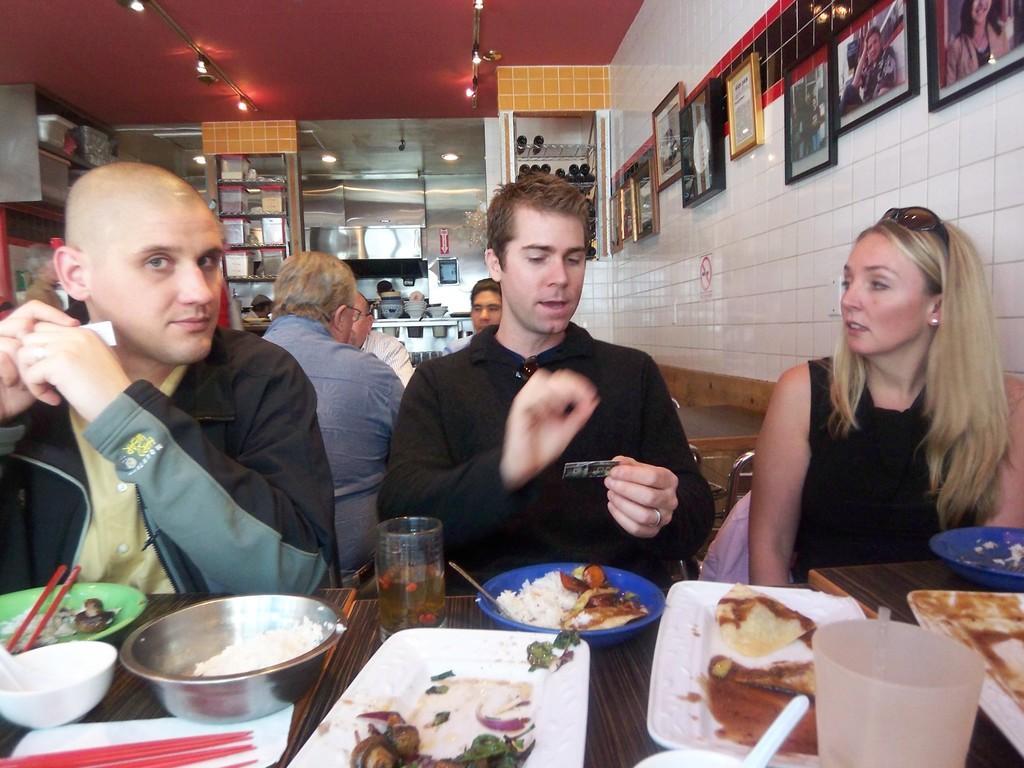Describe this image in one or two sentences. In this image we can see two men and one woman is sitting, in front of them one table is there. On table so many plates and bowls are there. In the plates food are present. The middle man is wearing black color t-shirt and the woman is wearing black color dress and the other man is wearing green shirt with black grey jacket. Behind them other people are sitting. The roof is in red color. The wall are in white color, to the walls photographs are attached. 